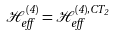<formula> <loc_0><loc_0><loc_500><loc_500>\mathcal { H } _ { e f f } ^ { ( 4 ) } = \mathcal { H } _ { e f f } ^ { ( 4 ) , C T _ { 2 } }</formula> 